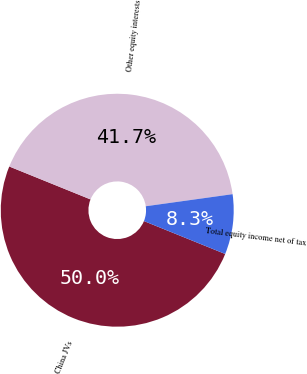<chart> <loc_0><loc_0><loc_500><loc_500><pie_chart><fcel>China JVs<fcel>Other equity interests<fcel>Total equity income net of tax<nl><fcel>50.0%<fcel>41.67%<fcel>8.33%<nl></chart> 